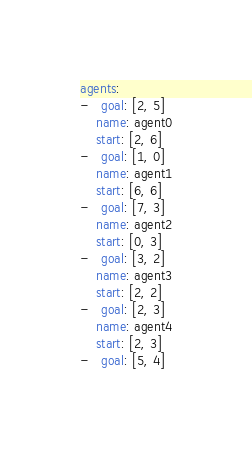Convert code to text. <code><loc_0><loc_0><loc_500><loc_500><_YAML_>agents:
-   goal: [2, 5]
    name: agent0
    start: [2, 6]
-   goal: [1, 0]
    name: agent1
    start: [6, 6]
-   goal: [7, 3]
    name: agent2
    start: [0, 3]
-   goal: [3, 2]
    name: agent3
    start: [2, 2]
-   goal: [2, 3]
    name: agent4
    start: [2, 3]
-   goal: [5, 4]</code> 